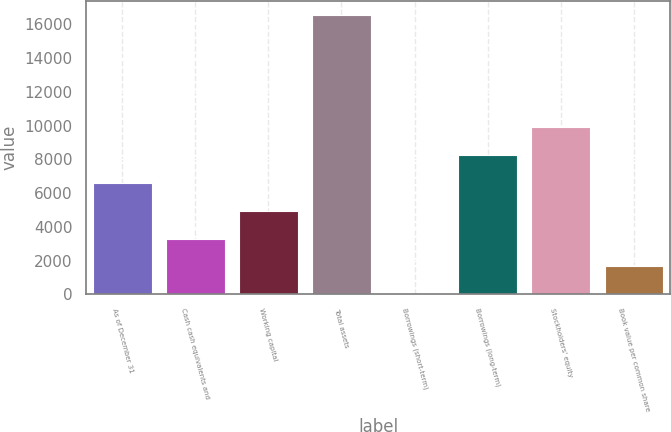Convert chart to OTSL. <chart><loc_0><loc_0><loc_500><loc_500><bar_chart><fcel>As of December 31<fcel>Cash cash equivalents and<fcel>Working capital<fcel>Total assets<fcel>Borrowings (short-term)<fcel>Borrowings (long-term)<fcel>Stockholders' equity<fcel>Book value per common share<nl><fcel>6621.4<fcel>3312.2<fcel>4966.8<fcel>16549<fcel>3<fcel>8276<fcel>9930.6<fcel>1657.6<nl></chart> 